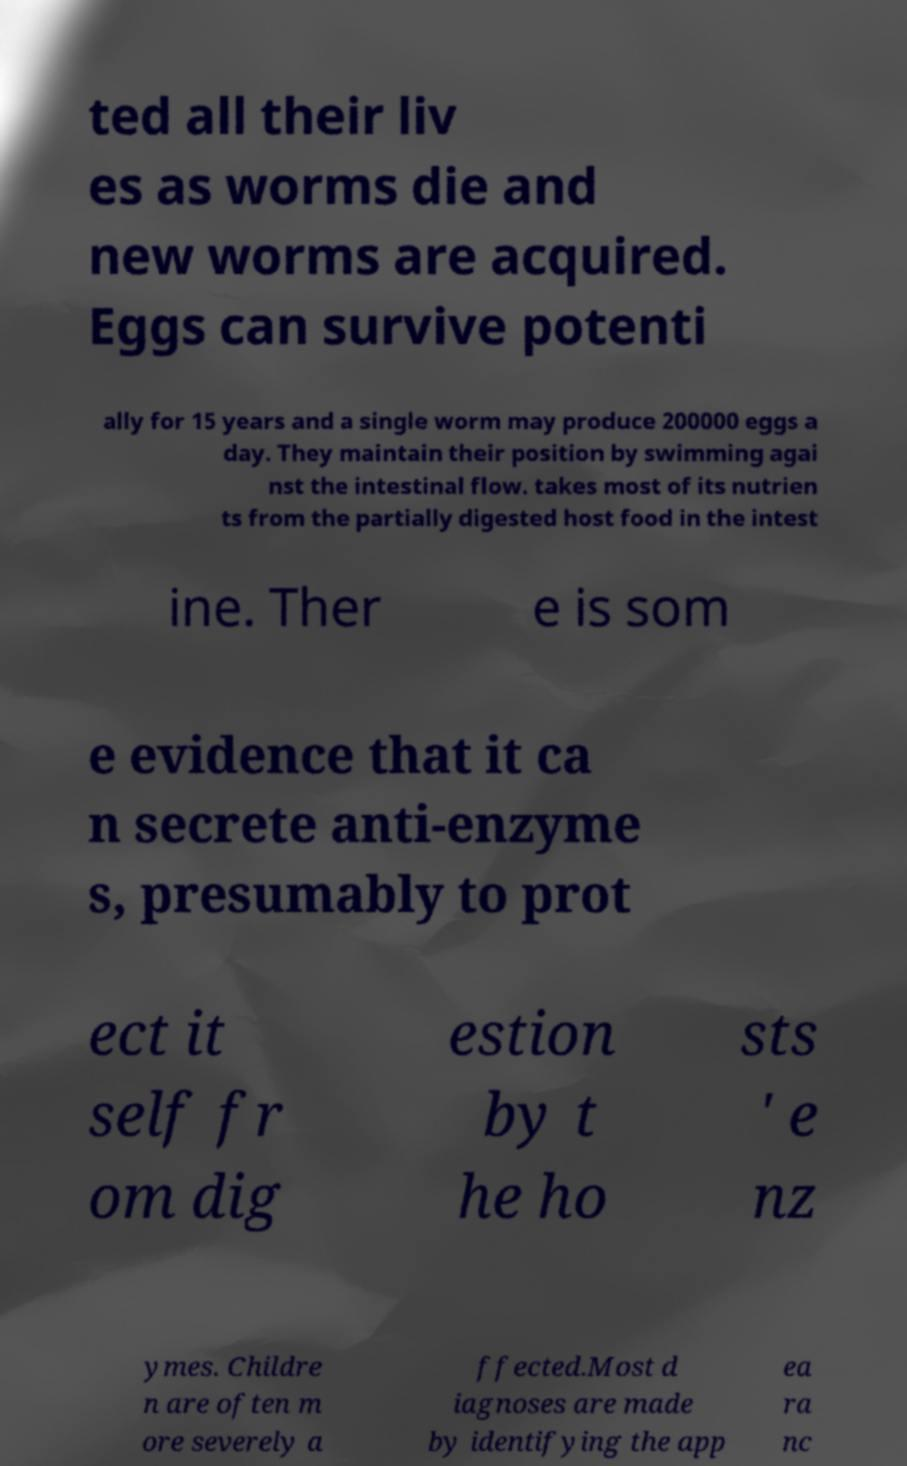Can you read and provide the text displayed in the image?This photo seems to have some interesting text. Can you extract and type it out for me? ted all their liv es as worms die and new worms are acquired. Eggs can survive potenti ally for 15 years and a single worm may produce 200000 eggs a day. They maintain their position by swimming agai nst the intestinal flow. takes most of its nutrien ts from the partially digested host food in the intest ine. Ther e is som e evidence that it ca n secrete anti-enzyme s, presumably to prot ect it self fr om dig estion by t he ho sts ' e nz ymes. Childre n are often m ore severely a ffected.Most d iagnoses are made by identifying the app ea ra nc 